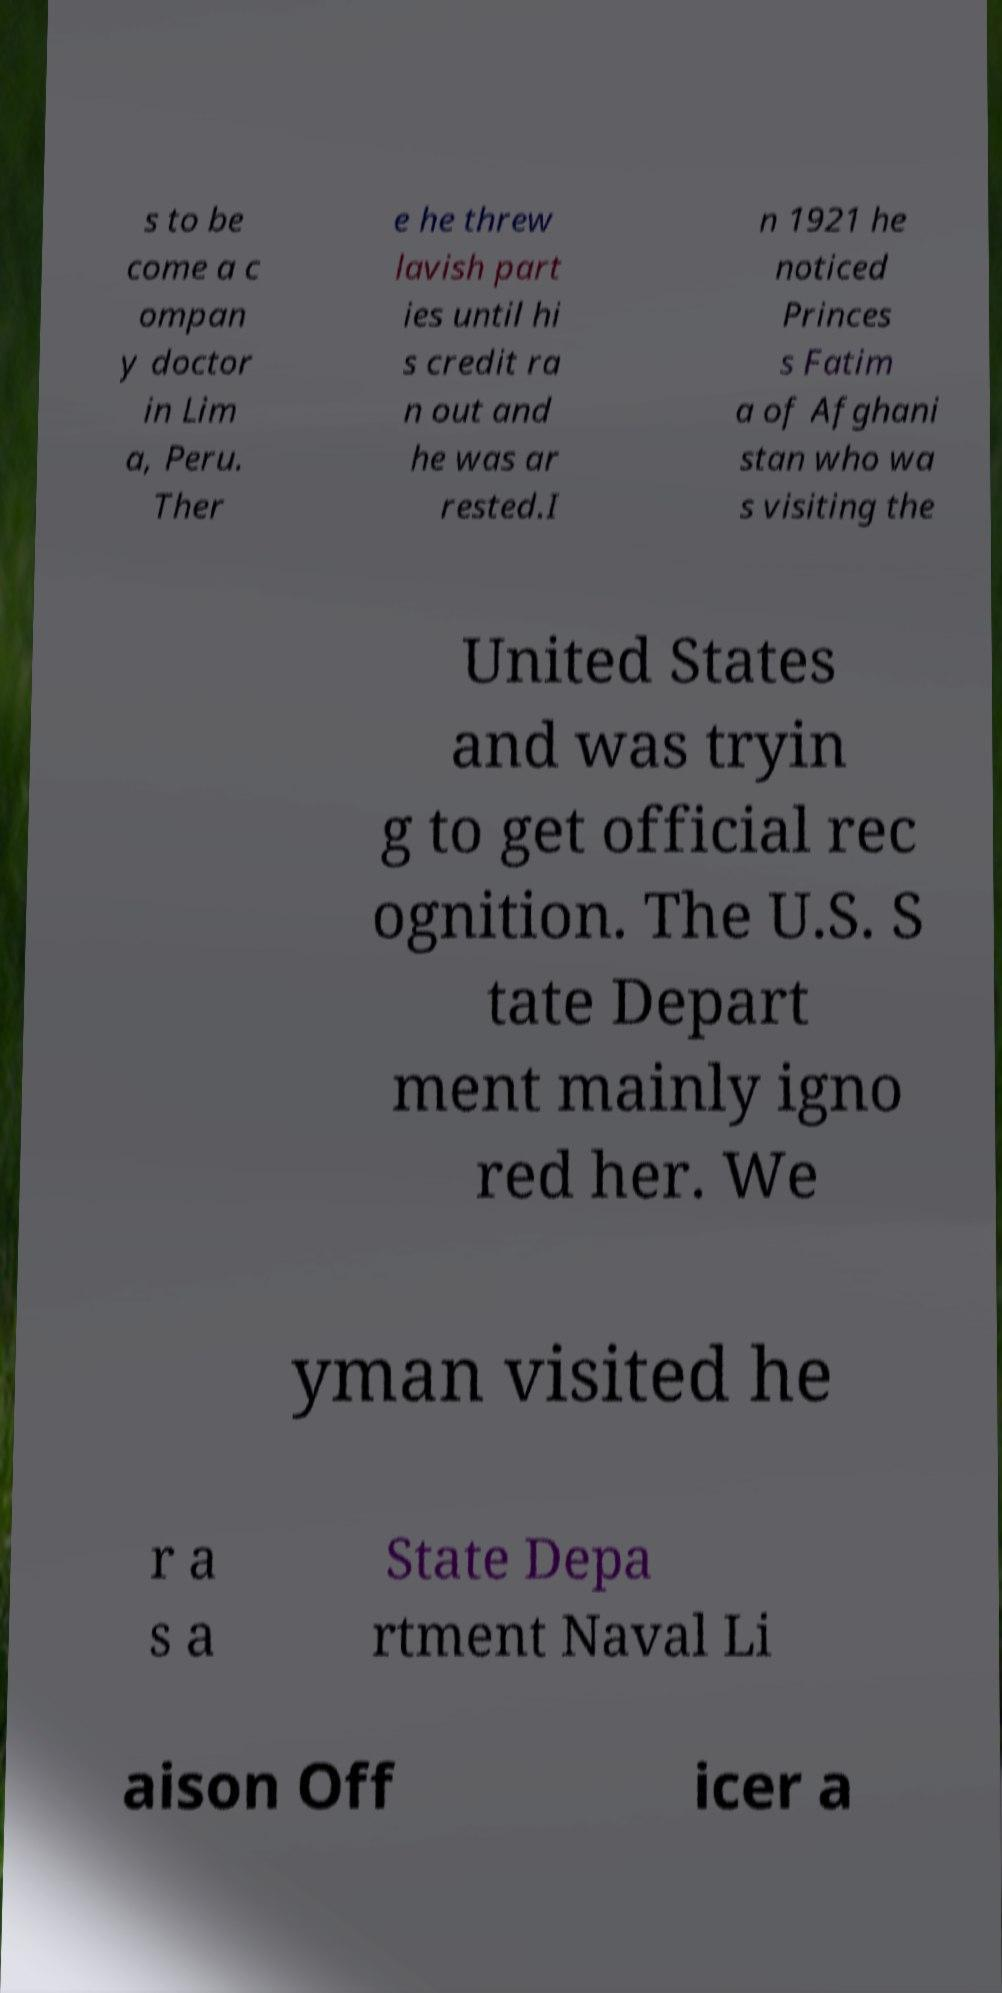What messages or text are displayed in this image? I need them in a readable, typed format. s to be come a c ompan y doctor in Lim a, Peru. Ther e he threw lavish part ies until hi s credit ra n out and he was ar rested.I n 1921 he noticed Princes s Fatim a of Afghani stan who wa s visiting the United States and was tryin g to get official rec ognition. The U.S. S tate Depart ment mainly igno red her. We yman visited he r a s a State Depa rtment Naval Li aison Off icer a 